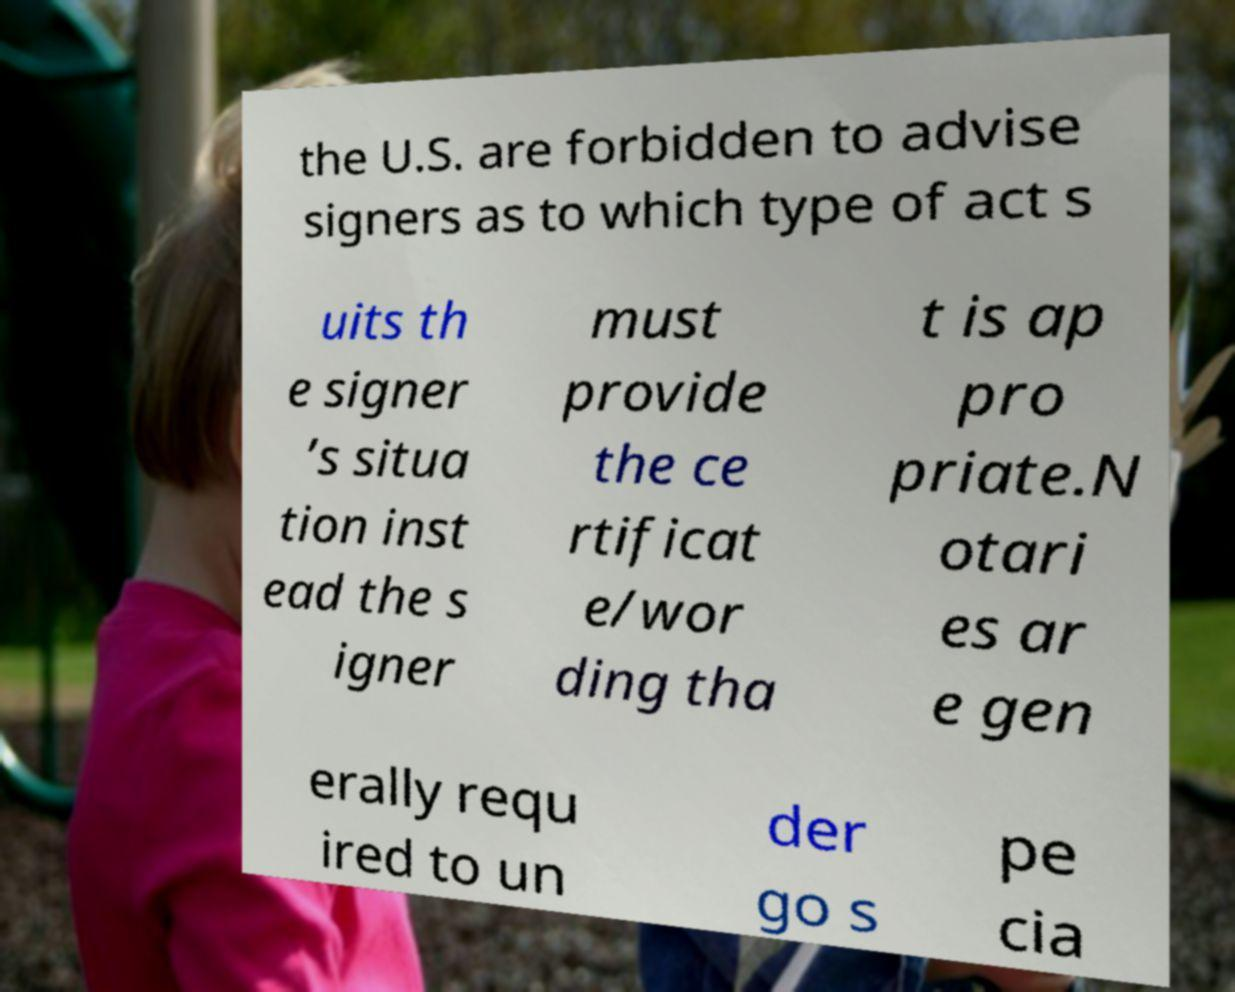Can you accurately transcribe the text from the provided image for me? the U.S. are forbidden to advise signers as to which type of act s uits th e signer ’s situa tion inst ead the s igner must provide the ce rtificat e/wor ding tha t is ap pro priate.N otari es ar e gen erally requ ired to un der go s pe cia 